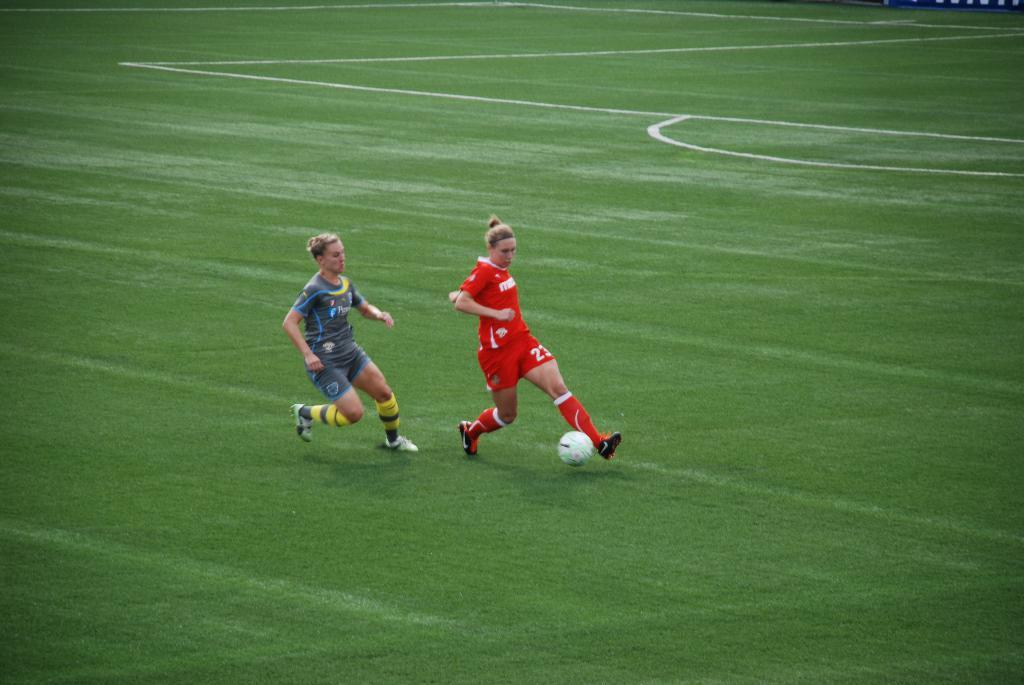<image>
Create a compact narrative representing the image presented. Player number 23 in the red uniform is kicking the soccer ball. 